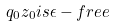Convert formula to latex. <formula><loc_0><loc_0><loc_500><loc_500>q _ { 0 } z _ { 0 } i s \epsilon - f r e e</formula> 